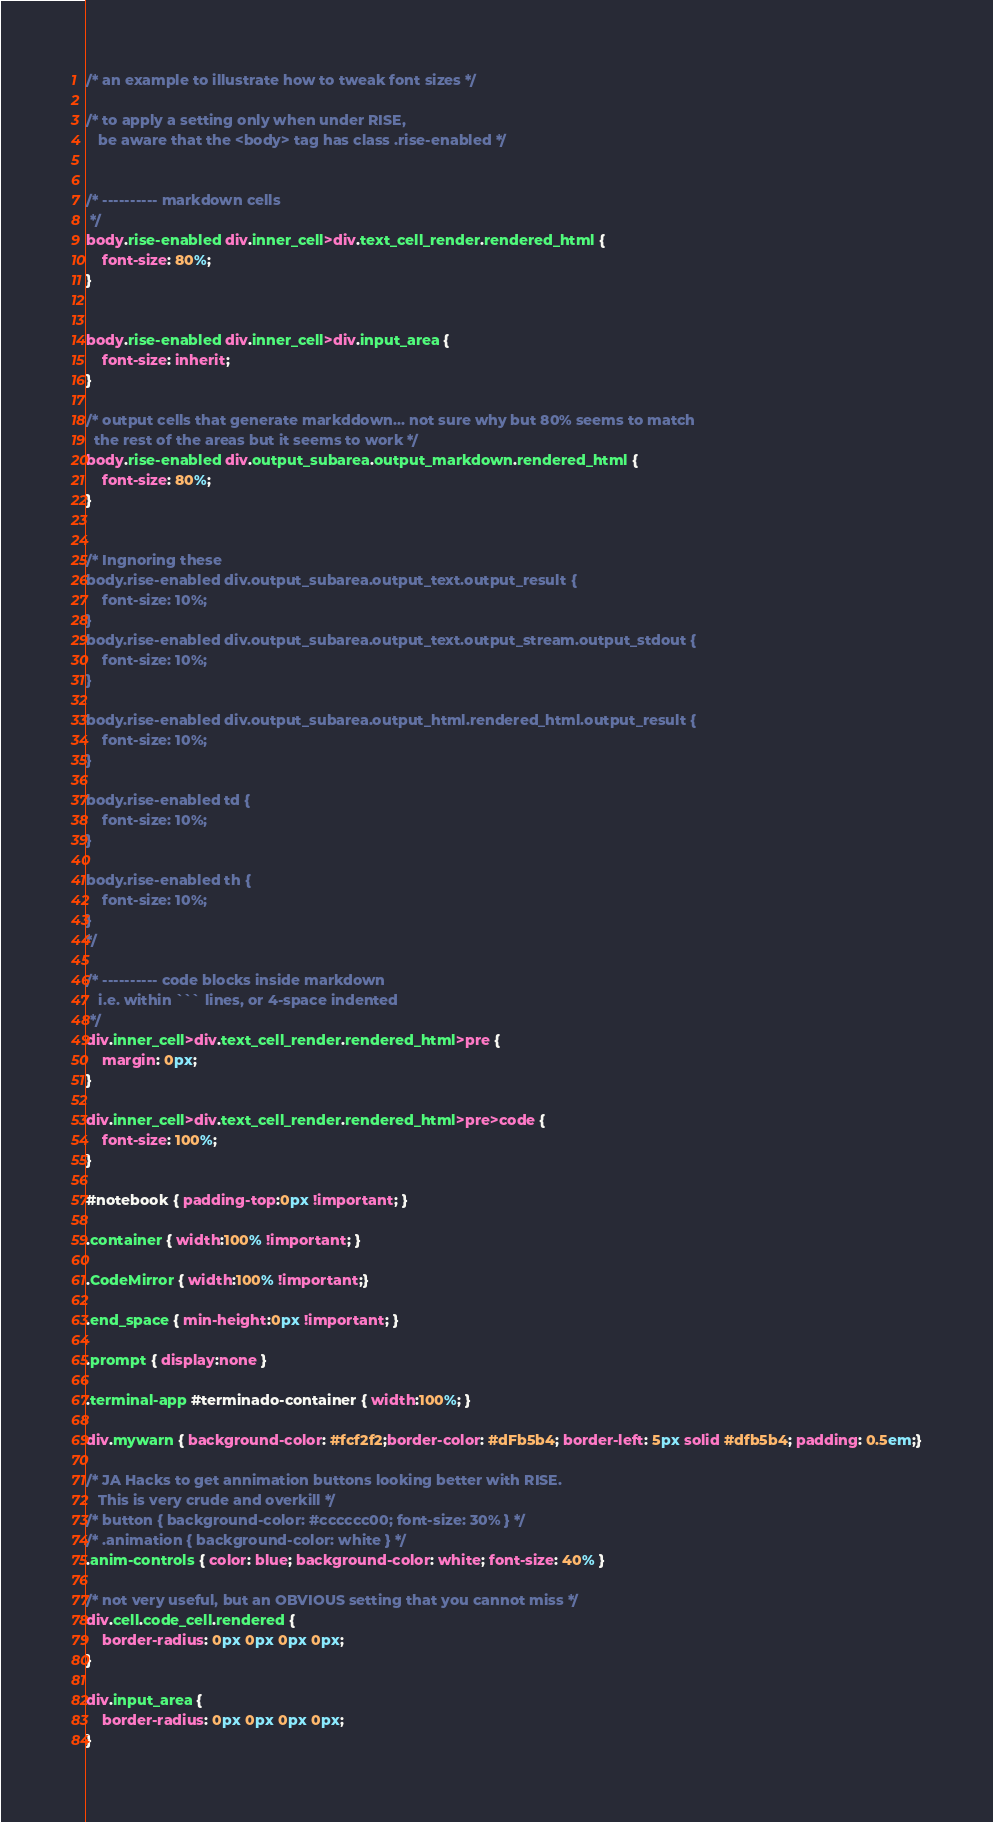Convert code to text. <code><loc_0><loc_0><loc_500><loc_500><_CSS_>
/* an example to illustrate how to tweak font sizes */

/* to apply a setting only when under RISE, 
   be aware that the <body> tag has class .rise-enabled */


/* ---------- markdown cells
 */
body.rise-enabled div.inner_cell>div.text_cell_render.rendered_html {
    font-size: 80%;
}


body.rise-enabled div.inner_cell>div.input_area {
    font-size: inherit;
}

/* output cells that generate markddown... not sure why but 80% seems to match 
  the rest of the areas but it seems to work */
body.rise-enabled div.output_subarea.output_markdown.rendered_html {
    font-size: 80%;
}


/* Ingnoring these 
body.rise-enabled div.output_subarea.output_text.output_result {
    font-size: 10%;
}
body.rise-enabled div.output_subarea.output_text.output_stream.output_stdout {
    font-size: 10%;
}

body.rise-enabled div.output_subarea.output_html.rendered_html.output_result {
    font-size: 10%;
}

body.rise-enabled td {
    font-size: 10%;
}

body.rise-enabled th {
    font-size: 10%;
}
*/

/* ---------- code blocks inside markdown
   i.e. within ``` lines, or 4-space indented
 */
div.inner_cell>div.text_cell_render.rendered_html>pre {
    margin: 0px;
}

div.inner_cell>div.text_cell_render.rendered_html>pre>code {
    font-size: 100%;
}

#notebook { padding-top:0px !important; }  

.container { width:100% !important; } 

.CodeMirror { width:100% !important;}

.end_space { min-height:0px !important; } 

.prompt { display:none }

.terminal-app #terminado-container { width:100%; }

div.mywarn { background-color: #fcf2f2;border-color: #dFb5b4; border-left: 5px solid #dfb5b4; padding: 0.5em;}

/* JA Hacks to get annimation buttons looking better with RISE.  
   This is very crude and overkill */
/* button { background-color: #cccccc00; font-size: 30% } */
/* .animation { background-color: white } */
.anim-controls { color: blue; background-color: white; font-size: 40% } 

/* not very useful, but an OBVIOUS setting that you cannot miss */
div.cell.code_cell.rendered {
    border-radius: 0px 0px 0px 0px;
}

div.input_area {
    border-radius: 0px 0px 0px 0px;
}


</code> 